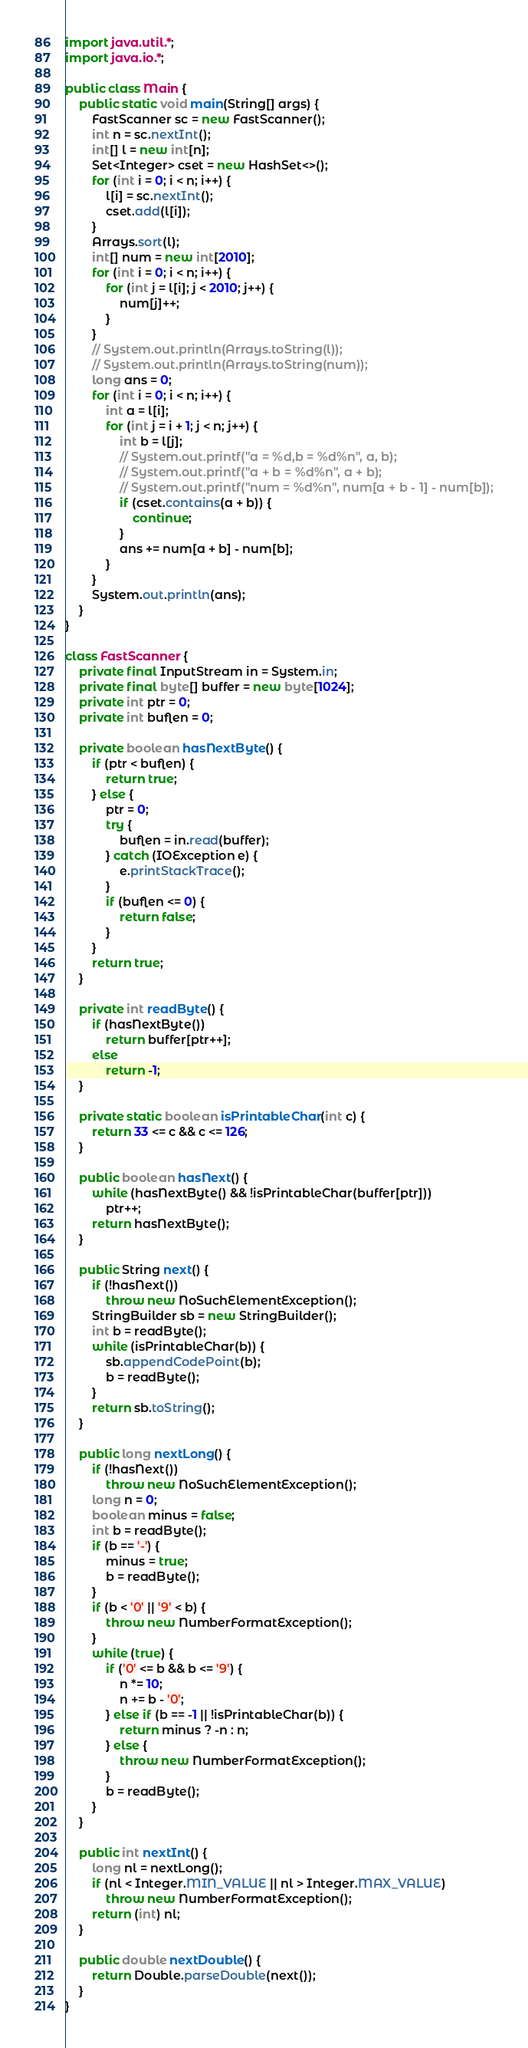<code> <loc_0><loc_0><loc_500><loc_500><_Java_>import java.util.*;
import java.io.*;

public class Main {
    public static void main(String[] args) {
        FastScanner sc = new FastScanner();
        int n = sc.nextInt();
        int[] l = new int[n];
        Set<Integer> cset = new HashSet<>();
        for (int i = 0; i < n; i++) {
            l[i] = sc.nextInt();
            cset.add(l[i]);
        }
        Arrays.sort(l);
        int[] num = new int[2010];
        for (int i = 0; i < n; i++) {
            for (int j = l[i]; j < 2010; j++) {
                num[j]++;
            }
        }
        // System.out.println(Arrays.toString(l));
        // System.out.println(Arrays.toString(num));
        long ans = 0;
        for (int i = 0; i < n; i++) {
            int a = l[i];
            for (int j = i + 1; j < n; j++) {
                int b = l[j];
                // System.out.printf("a = %d,b = %d%n", a, b);
                // System.out.printf("a + b = %d%n", a + b);
                // System.out.printf("num = %d%n", num[a + b - 1] - num[b]);
                if (cset.contains(a + b)) {
                    continue;
                }
                ans += num[a + b] - num[b];
            }
        }
        System.out.println(ans);
    }
}

class FastScanner {
    private final InputStream in = System.in;
    private final byte[] buffer = new byte[1024];
    private int ptr = 0;
    private int buflen = 0;

    private boolean hasNextByte() {
        if (ptr < buflen) {
            return true;
        } else {
            ptr = 0;
            try {
                buflen = in.read(buffer);
            } catch (IOException e) {
                e.printStackTrace();
            }
            if (buflen <= 0) {
                return false;
            }
        }
        return true;
    }

    private int readByte() {
        if (hasNextByte())
            return buffer[ptr++];
        else
            return -1;
    }

    private static boolean isPrintableChar(int c) {
        return 33 <= c && c <= 126;
    }

    public boolean hasNext() {
        while (hasNextByte() && !isPrintableChar(buffer[ptr]))
            ptr++;
        return hasNextByte();
    }

    public String next() {
        if (!hasNext())
            throw new NoSuchElementException();
        StringBuilder sb = new StringBuilder();
        int b = readByte();
        while (isPrintableChar(b)) {
            sb.appendCodePoint(b);
            b = readByte();
        }
        return sb.toString();
    }

    public long nextLong() {
        if (!hasNext())
            throw new NoSuchElementException();
        long n = 0;
        boolean minus = false;
        int b = readByte();
        if (b == '-') {
            minus = true;
            b = readByte();
        }
        if (b < '0' || '9' < b) {
            throw new NumberFormatException();
        }
        while (true) {
            if ('0' <= b && b <= '9') {
                n *= 10;
                n += b - '0';
            } else if (b == -1 || !isPrintableChar(b)) {
                return minus ? -n : n;
            } else {
                throw new NumberFormatException();
            }
            b = readByte();
        }
    }

    public int nextInt() {
        long nl = nextLong();
        if (nl < Integer.MIN_VALUE || nl > Integer.MAX_VALUE)
            throw new NumberFormatException();
        return (int) nl;
    }

    public double nextDouble() {
        return Double.parseDouble(next());
    }
}
</code> 